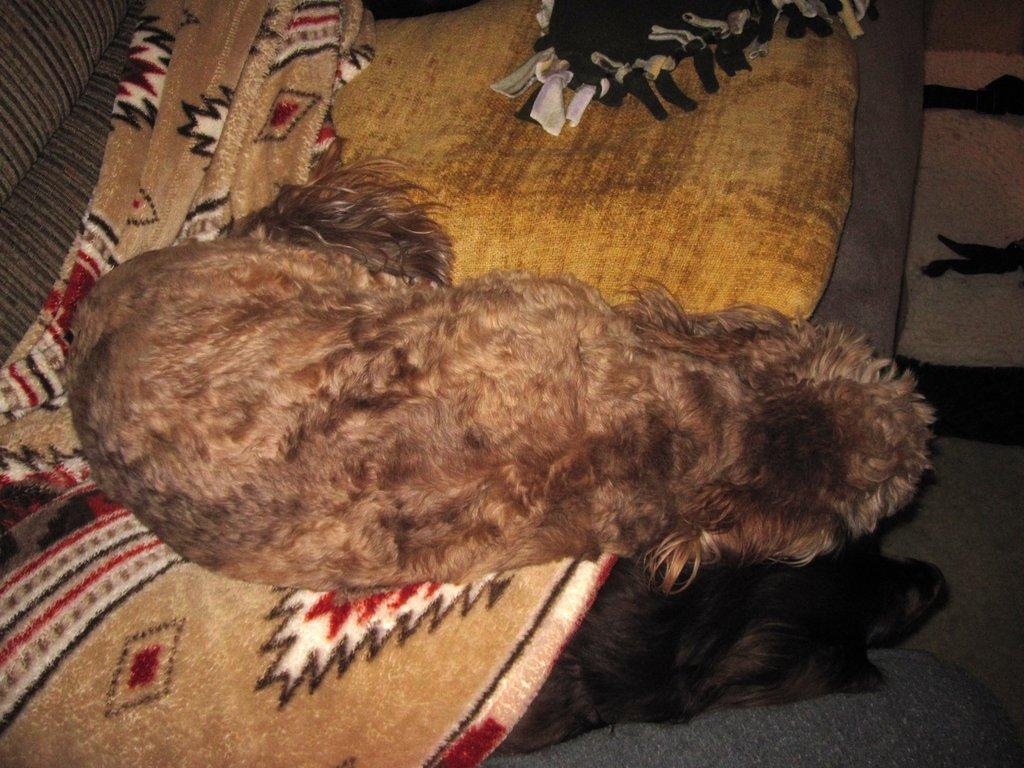How many dogs are in the image? There are two dogs in the image. Where are the dogs located in the image? The dogs are on a couch in the image. What else can be seen in the image besides the dogs? There are clothes visible in the image. Can you tell me how the dogs are walking on the couch in the image? The dogs are not walking on the couch in the image; they are stationary while sitting or lying down. What type of animal is the yak in the image? There is no yak present in the image. 